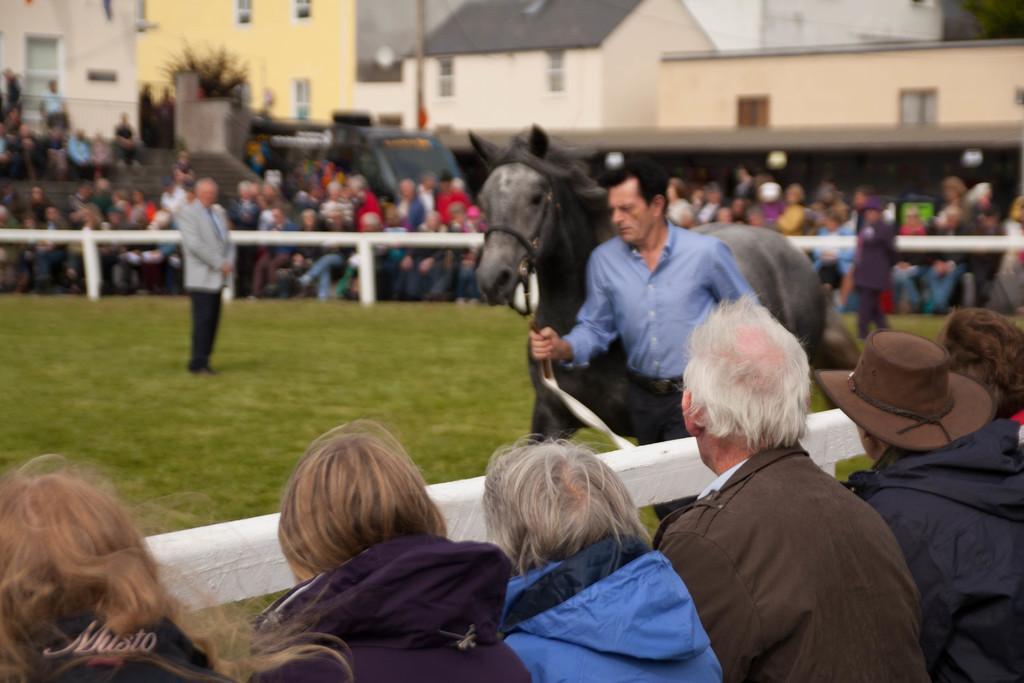Could you give a brief overview of what you see in this image? The person wearing blue shirt is holding a rope which is tightened to the horse and there are group of audience and houses around him. 